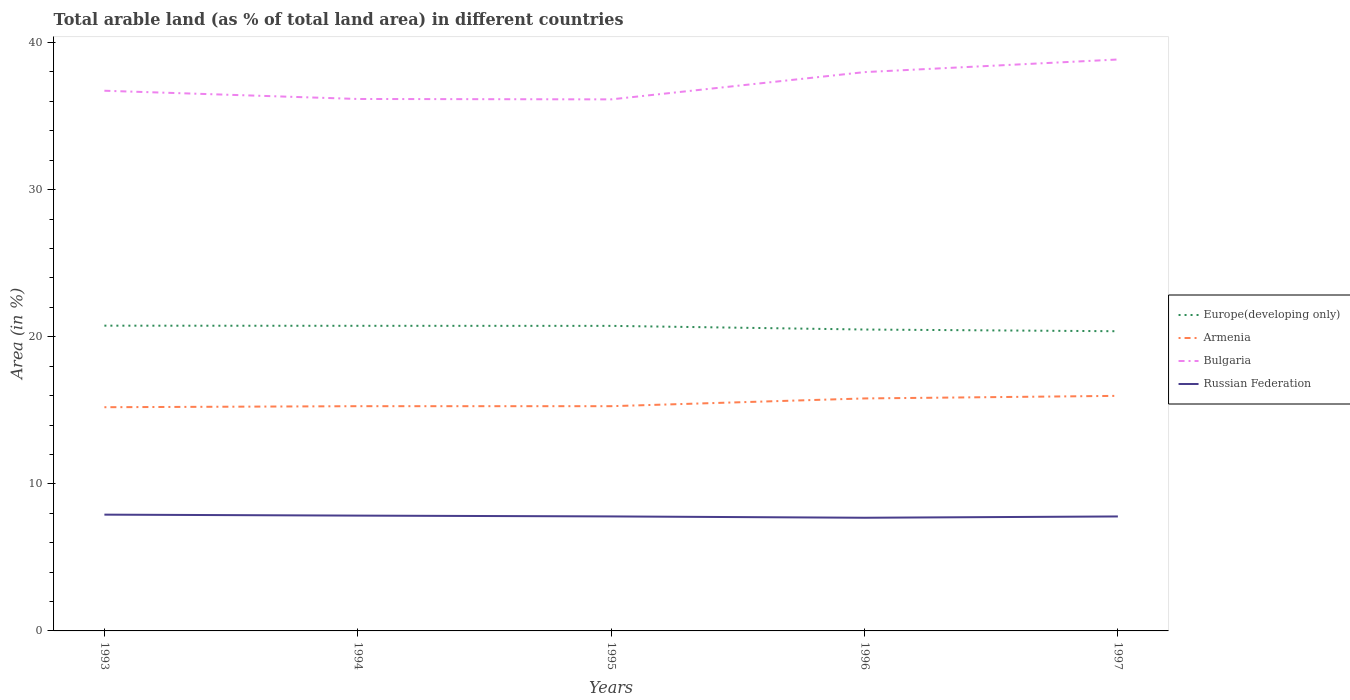Does the line corresponding to Russian Federation intersect with the line corresponding to Europe(developing only)?
Your answer should be very brief. No. Is the number of lines equal to the number of legend labels?
Offer a terse response. Yes. Across all years, what is the maximum percentage of arable land in Europe(developing only)?
Offer a very short reply. 20.37. What is the total percentage of arable land in Russian Federation in the graph?
Your answer should be very brief. 0.06. What is the difference between the highest and the second highest percentage of arable land in Bulgaria?
Your answer should be compact. 2.71. Is the percentage of arable land in Armenia strictly greater than the percentage of arable land in Europe(developing only) over the years?
Make the answer very short. Yes. How many lines are there?
Offer a terse response. 4. How many years are there in the graph?
Ensure brevity in your answer.  5. How many legend labels are there?
Provide a succinct answer. 4. How are the legend labels stacked?
Give a very brief answer. Vertical. What is the title of the graph?
Ensure brevity in your answer.  Total arable land (as % of total land area) in different countries. Does "Nigeria" appear as one of the legend labels in the graph?
Make the answer very short. No. What is the label or title of the Y-axis?
Offer a terse response. Area (in %). What is the Area (in %) of Europe(developing only) in 1993?
Provide a short and direct response. 20.75. What is the Area (in %) in Armenia in 1993?
Your response must be concise. 15.21. What is the Area (in %) in Bulgaria in 1993?
Provide a succinct answer. 36.73. What is the Area (in %) in Russian Federation in 1993?
Give a very brief answer. 7.91. What is the Area (in %) of Europe(developing only) in 1994?
Keep it short and to the point. 20.74. What is the Area (in %) in Armenia in 1994?
Keep it short and to the point. 15.28. What is the Area (in %) in Bulgaria in 1994?
Provide a succinct answer. 36.17. What is the Area (in %) of Russian Federation in 1994?
Give a very brief answer. 7.84. What is the Area (in %) of Europe(developing only) in 1995?
Ensure brevity in your answer.  20.74. What is the Area (in %) in Armenia in 1995?
Your response must be concise. 15.28. What is the Area (in %) of Bulgaria in 1995?
Offer a terse response. 36.14. What is the Area (in %) in Russian Federation in 1995?
Offer a terse response. 7.78. What is the Area (in %) of Europe(developing only) in 1996?
Give a very brief answer. 20.49. What is the Area (in %) in Armenia in 1996?
Provide a short and direct response. 15.81. What is the Area (in %) of Bulgaria in 1996?
Give a very brief answer. 37.99. What is the Area (in %) of Russian Federation in 1996?
Make the answer very short. 7.69. What is the Area (in %) in Europe(developing only) in 1997?
Your answer should be compact. 20.37. What is the Area (in %) in Armenia in 1997?
Make the answer very short. 15.98. What is the Area (in %) in Bulgaria in 1997?
Keep it short and to the point. 38.85. What is the Area (in %) in Russian Federation in 1997?
Offer a terse response. 7.78. Across all years, what is the maximum Area (in %) in Europe(developing only)?
Provide a short and direct response. 20.75. Across all years, what is the maximum Area (in %) of Armenia?
Offer a terse response. 15.98. Across all years, what is the maximum Area (in %) in Bulgaria?
Offer a terse response. 38.85. Across all years, what is the maximum Area (in %) in Russian Federation?
Provide a short and direct response. 7.91. Across all years, what is the minimum Area (in %) in Europe(developing only)?
Your answer should be very brief. 20.37. Across all years, what is the minimum Area (in %) in Armenia?
Provide a succinct answer. 15.21. Across all years, what is the minimum Area (in %) in Bulgaria?
Offer a terse response. 36.14. Across all years, what is the minimum Area (in %) of Russian Federation?
Offer a very short reply. 7.69. What is the total Area (in %) in Europe(developing only) in the graph?
Give a very brief answer. 103.1. What is the total Area (in %) in Armenia in the graph?
Give a very brief answer. 77.56. What is the total Area (in %) in Bulgaria in the graph?
Your answer should be very brief. 185.87. What is the total Area (in %) in Russian Federation in the graph?
Provide a short and direct response. 39.01. What is the difference between the Area (in %) of Europe(developing only) in 1993 and that in 1994?
Ensure brevity in your answer.  0.01. What is the difference between the Area (in %) of Armenia in 1993 and that in 1994?
Offer a terse response. -0.07. What is the difference between the Area (in %) of Bulgaria in 1993 and that in 1994?
Ensure brevity in your answer.  0.56. What is the difference between the Area (in %) in Russian Federation in 1993 and that in 1994?
Give a very brief answer. 0.07. What is the difference between the Area (in %) in Europe(developing only) in 1993 and that in 1995?
Offer a terse response. 0.01. What is the difference between the Area (in %) in Armenia in 1993 and that in 1995?
Keep it short and to the point. -0.07. What is the difference between the Area (in %) in Bulgaria in 1993 and that in 1995?
Provide a succinct answer. 0.59. What is the difference between the Area (in %) in Russian Federation in 1993 and that in 1995?
Provide a succinct answer. 0.12. What is the difference between the Area (in %) in Europe(developing only) in 1993 and that in 1996?
Provide a succinct answer. 0.26. What is the difference between the Area (in %) of Armenia in 1993 and that in 1996?
Provide a succinct answer. -0.6. What is the difference between the Area (in %) in Bulgaria in 1993 and that in 1996?
Make the answer very short. -1.27. What is the difference between the Area (in %) of Russian Federation in 1993 and that in 1996?
Offer a terse response. 0.21. What is the difference between the Area (in %) in Europe(developing only) in 1993 and that in 1997?
Provide a short and direct response. 0.38. What is the difference between the Area (in %) in Armenia in 1993 and that in 1997?
Offer a terse response. -0.77. What is the difference between the Area (in %) of Bulgaria in 1993 and that in 1997?
Keep it short and to the point. -2.12. What is the difference between the Area (in %) of Russian Federation in 1993 and that in 1997?
Your answer should be very brief. 0.12. What is the difference between the Area (in %) in Europe(developing only) in 1994 and that in 1995?
Ensure brevity in your answer.  0. What is the difference between the Area (in %) in Armenia in 1994 and that in 1995?
Your answer should be very brief. 0. What is the difference between the Area (in %) in Bulgaria in 1994 and that in 1995?
Give a very brief answer. 0.03. What is the difference between the Area (in %) of Russian Federation in 1994 and that in 1995?
Keep it short and to the point. 0.05. What is the difference between the Area (in %) in Europe(developing only) in 1994 and that in 1996?
Your response must be concise. 0.25. What is the difference between the Area (in %) of Armenia in 1994 and that in 1996?
Offer a very short reply. -0.53. What is the difference between the Area (in %) in Bulgaria in 1994 and that in 1996?
Give a very brief answer. -1.83. What is the difference between the Area (in %) of Russian Federation in 1994 and that in 1996?
Ensure brevity in your answer.  0.14. What is the difference between the Area (in %) of Europe(developing only) in 1994 and that in 1997?
Offer a terse response. 0.37. What is the difference between the Area (in %) in Armenia in 1994 and that in 1997?
Your response must be concise. -0.7. What is the difference between the Area (in %) in Bulgaria in 1994 and that in 1997?
Your response must be concise. -2.68. What is the difference between the Area (in %) of Russian Federation in 1994 and that in 1997?
Make the answer very short. 0.06. What is the difference between the Area (in %) in Europe(developing only) in 1995 and that in 1996?
Provide a succinct answer. 0.25. What is the difference between the Area (in %) in Armenia in 1995 and that in 1996?
Your answer should be compact. -0.53. What is the difference between the Area (in %) in Bulgaria in 1995 and that in 1996?
Your answer should be compact. -1.85. What is the difference between the Area (in %) of Russian Federation in 1995 and that in 1996?
Your answer should be very brief. 0.09. What is the difference between the Area (in %) of Europe(developing only) in 1995 and that in 1997?
Your response must be concise. 0.37. What is the difference between the Area (in %) of Armenia in 1995 and that in 1997?
Your answer should be compact. -0.7. What is the difference between the Area (in %) in Bulgaria in 1995 and that in 1997?
Your response must be concise. -2.71. What is the difference between the Area (in %) of Russian Federation in 1995 and that in 1997?
Offer a very short reply. 0. What is the difference between the Area (in %) of Europe(developing only) in 1996 and that in 1997?
Your answer should be compact. 0.12. What is the difference between the Area (in %) in Armenia in 1996 and that in 1997?
Your response must be concise. -0.18. What is the difference between the Area (in %) in Bulgaria in 1996 and that in 1997?
Your response must be concise. -0.86. What is the difference between the Area (in %) of Russian Federation in 1996 and that in 1997?
Give a very brief answer. -0.09. What is the difference between the Area (in %) of Europe(developing only) in 1993 and the Area (in %) of Armenia in 1994?
Your response must be concise. 5.47. What is the difference between the Area (in %) of Europe(developing only) in 1993 and the Area (in %) of Bulgaria in 1994?
Offer a terse response. -15.41. What is the difference between the Area (in %) in Europe(developing only) in 1993 and the Area (in %) in Russian Federation in 1994?
Keep it short and to the point. 12.91. What is the difference between the Area (in %) in Armenia in 1993 and the Area (in %) in Bulgaria in 1994?
Provide a succinct answer. -20.96. What is the difference between the Area (in %) of Armenia in 1993 and the Area (in %) of Russian Federation in 1994?
Offer a very short reply. 7.37. What is the difference between the Area (in %) in Bulgaria in 1993 and the Area (in %) in Russian Federation in 1994?
Provide a succinct answer. 28.89. What is the difference between the Area (in %) of Europe(developing only) in 1993 and the Area (in %) of Armenia in 1995?
Provide a short and direct response. 5.47. What is the difference between the Area (in %) in Europe(developing only) in 1993 and the Area (in %) in Bulgaria in 1995?
Offer a very short reply. -15.38. What is the difference between the Area (in %) in Europe(developing only) in 1993 and the Area (in %) in Russian Federation in 1995?
Your answer should be very brief. 12.97. What is the difference between the Area (in %) in Armenia in 1993 and the Area (in %) in Bulgaria in 1995?
Your response must be concise. -20.93. What is the difference between the Area (in %) in Armenia in 1993 and the Area (in %) in Russian Federation in 1995?
Provide a succinct answer. 7.42. What is the difference between the Area (in %) in Bulgaria in 1993 and the Area (in %) in Russian Federation in 1995?
Your response must be concise. 28.94. What is the difference between the Area (in %) in Europe(developing only) in 1993 and the Area (in %) in Armenia in 1996?
Your answer should be compact. 4.95. What is the difference between the Area (in %) of Europe(developing only) in 1993 and the Area (in %) of Bulgaria in 1996?
Your answer should be very brief. -17.24. What is the difference between the Area (in %) in Europe(developing only) in 1993 and the Area (in %) in Russian Federation in 1996?
Offer a terse response. 13.06. What is the difference between the Area (in %) in Armenia in 1993 and the Area (in %) in Bulgaria in 1996?
Offer a very short reply. -22.78. What is the difference between the Area (in %) in Armenia in 1993 and the Area (in %) in Russian Federation in 1996?
Provide a succinct answer. 7.51. What is the difference between the Area (in %) of Bulgaria in 1993 and the Area (in %) of Russian Federation in 1996?
Offer a very short reply. 29.03. What is the difference between the Area (in %) in Europe(developing only) in 1993 and the Area (in %) in Armenia in 1997?
Make the answer very short. 4.77. What is the difference between the Area (in %) of Europe(developing only) in 1993 and the Area (in %) of Bulgaria in 1997?
Give a very brief answer. -18.1. What is the difference between the Area (in %) of Europe(developing only) in 1993 and the Area (in %) of Russian Federation in 1997?
Make the answer very short. 12.97. What is the difference between the Area (in %) in Armenia in 1993 and the Area (in %) in Bulgaria in 1997?
Make the answer very short. -23.64. What is the difference between the Area (in %) of Armenia in 1993 and the Area (in %) of Russian Federation in 1997?
Give a very brief answer. 7.43. What is the difference between the Area (in %) of Bulgaria in 1993 and the Area (in %) of Russian Federation in 1997?
Offer a very short reply. 28.94. What is the difference between the Area (in %) in Europe(developing only) in 1994 and the Area (in %) in Armenia in 1995?
Offer a very short reply. 5.47. What is the difference between the Area (in %) in Europe(developing only) in 1994 and the Area (in %) in Bulgaria in 1995?
Give a very brief answer. -15.39. What is the difference between the Area (in %) of Europe(developing only) in 1994 and the Area (in %) of Russian Federation in 1995?
Provide a succinct answer. 12.96. What is the difference between the Area (in %) of Armenia in 1994 and the Area (in %) of Bulgaria in 1995?
Offer a very short reply. -20.86. What is the difference between the Area (in %) of Armenia in 1994 and the Area (in %) of Russian Federation in 1995?
Offer a terse response. 7.49. What is the difference between the Area (in %) of Bulgaria in 1994 and the Area (in %) of Russian Federation in 1995?
Your answer should be very brief. 28.38. What is the difference between the Area (in %) in Europe(developing only) in 1994 and the Area (in %) in Armenia in 1996?
Your response must be concise. 4.94. What is the difference between the Area (in %) in Europe(developing only) in 1994 and the Area (in %) in Bulgaria in 1996?
Give a very brief answer. -17.25. What is the difference between the Area (in %) in Europe(developing only) in 1994 and the Area (in %) in Russian Federation in 1996?
Offer a very short reply. 13.05. What is the difference between the Area (in %) in Armenia in 1994 and the Area (in %) in Bulgaria in 1996?
Provide a short and direct response. -22.71. What is the difference between the Area (in %) in Armenia in 1994 and the Area (in %) in Russian Federation in 1996?
Your answer should be very brief. 7.58. What is the difference between the Area (in %) in Bulgaria in 1994 and the Area (in %) in Russian Federation in 1996?
Offer a very short reply. 28.47. What is the difference between the Area (in %) in Europe(developing only) in 1994 and the Area (in %) in Armenia in 1997?
Make the answer very short. 4.76. What is the difference between the Area (in %) in Europe(developing only) in 1994 and the Area (in %) in Bulgaria in 1997?
Ensure brevity in your answer.  -18.11. What is the difference between the Area (in %) in Europe(developing only) in 1994 and the Area (in %) in Russian Federation in 1997?
Provide a short and direct response. 12.96. What is the difference between the Area (in %) of Armenia in 1994 and the Area (in %) of Bulgaria in 1997?
Ensure brevity in your answer.  -23.57. What is the difference between the Area (in %) of Armenia in 1994 and the Area (in %) of Russian Federation in 1997?
Keep it short and to the point. 7.5. What is the difference between the Area (in %) in Bulgaria in 1994 and the Area (in %) in Russian Federation in 1997?
Your answer should be compact. 28.38. What is the difference between the Area (in %) of Europe(developing only) in 1995 and the Area (in %) of Armenia in 1996?
Keep it short and to the point. 4.93. What is the difference between the Area (in %) of Europe(developing only) in 1995 and the Area (in %) of Bulgaria in 1996?
Provide a succinct answer. -17.25. What is the difference between the Area (in %) in Europe(developing only) in 1995 and the Area (in %) in Russian Federation in 1996?
Make the answer very short. 13.05. What is the difference between the Area (in %) of Armenia in 1995 and the Area (in %) of Bulgaria in 1996?
Offer a very short reply. -22.71. What is the difference between the Area (in %) of Armenia in 1995 and the Area (in %) of Russian Federation in 1996?
Provide a short and direct response. 7.58. What is the difference between the Area (in %) in Bulgaria in 1995 and the Area (in %) in Russian Federation in 1996?
Make the answer very short. 28.44. What is the difference between the Area (in %) in Europe(developing only) in 1995 and the Area (in %) in Armenia in 1997?
Provide a short and direct response. 4.76. What is the difference between the Area (in %) in Europe(developing only) in 1995 and the Area (in %) in Bulgaria in 1997?
Provide a short and direct response. -18.11. What is the difference between the Area (in %) of Europe(developing only) in 1995 and the Area (in %) of Russian Federation in 1997?
Keep it short and to the point. 12.96. What is the difference between the Area (in %) of Armenia in 1995 and the Area (in %) of Bulgaria in 1997?
Provide a succinct answer. -23.57. What is the difference between the Area (in %) in Armenia in 1995 and the Area (in %) in Russian Federation in 1997?
Make the answer very short. 7.5. What is the difference between the Area (in %) in Bulgaria in 1995 and the Area (in %) in Russian Federation in 1997?
Your answer should be very brief. 28.36. What is the difference between the Area (in %) of Europe(developing only) in 1996 and the Area (in %) of Armenia in 1997?
Keep it short and to the point. 4.51. What is the difference between the Area (in %) in Europe(developing only) in 1996 and the Area (in %) in Bulgaria in 1997?
Offer a terse response. -18.36. What is the difference between the Area (in %) in Europe(developing only) in 1996 and the Area (in %) in Russian Federation in 1997?
Ensure brevity in your answer.  12.71. What is the difference between the Area (in %) of Armenia in 1996 and the Area (in %) of Bulgaria in 1997?
Offer a terse response. -23.04. What is the difference between the Area (in %) of Armenia in 1996 and the Area (in %) of Russian Federation in 1997?
Your answer should be very brief. 8.02. What is the difference between the Area (in %) in Bulgaria in 1996 and the Area (in %) in Russian Federation in 1997?
Your response must be concise. 30.21. What is the average Area (in %) of Europe(developing only) per year?
Keep it short and to the point. 20.62. What is the average Area (in %) in Armenia per year?
Ensure brevity in your answer.  15.51. What is the average Area (in %) in Bulgaria per year?
Provide a short and direct response. 37.17. What is the average Area (in %) of Russian Federation per year?
Your response must be concise. 7.8. In the year 1993, what is the difference between the Area (in %) of Europe(developing only) and Area (in %) of Armenia?
Offer a terse response. 5.54. In the year 1993, what is the difference between the Area (in %) of Europe(developing only) and Area (in %) of Bulgaria?
Provide a succinct answer. -15.97. In the year 1993, what is the difference between the Area (in %) in Europe(developing only) and Area (in %) in Russian Federation?
Your response must be concise. 12.85. In the year 1993, what is the difference between the Area (in %) in Armenia and Area (in %) in Bulgaria?
Make the answer very short. -21.52. In the year 1993, what is the difference between the Area (in %) in Armenia and Area (in %) in Russian Federation?
Your answer should be compact. 7.3. In the year 1993, what is the difference between the Area (in %) in Bulgaria and Area (in %) in Russian Federation?
Your response must be concise. 28.82. In the year 1994, what is the difference between the Area (in %) of Europe(developing only) and Area (in %) of Armenia?
Provide a succinct answer. 5.47. In the year 1994, what is the difference between the Area (in %) in Europe(developing only) and Area (in %) in Bulgaria?
Your response must be concise. -15.42. In the year 1994, what is the difference between the Area (in %) in Europe(developing only) and Area (in %) in Russian Federation?
Provide a short and direct response. 12.9. In the year 1994, what is the difference between the Area (in %) in Armenia and Area (in %) in Bulgaria?
Provide a succinct answer. -20.89. In the year 1994, what is the difference between the Area (in %) of Armenia and Area (in %) of Russian Federation?
Your answer should be compact. 7.44. In the year 1994, what is the difference between the Area (in %) of Bulgaria and Area (in %) of Russian Federation?
Make the answer very short. 28.33. In the year 1995, what is the difference between the Area (in %) in Europe(developing only) and Area (in %) in Armenia?
Your response must be concise. 5.46. In the year 1995, what is the difference between the Area (in %) of Europe(developing only) and Area (in %) of Bulgaria?
Ensure brevity in your answer.  -15.4. In the year 1995, what is the difference between the Area (in %) of Europe(developing only) and Area (in %) of Russian Federation?
Your response must be concise. 12.96. In the year 1995, what is the difference between the Area (in %) of Armenia and Area (in %) of Bulgaria?
Offer a terse response. -20.86. In the year 1995, what is the difference between the Area (in %) in Armenia and Area (in %) in Russian Federation?
Keep it short and to the point. 7.49. In the year 1995, what is the difference between the Area (in %) in Bulgaria and Area (in %) in Russian Federation?
Give a very brief answer. 28.35. In the year 1996, what is the difference between the Area (in %) of Europe(developing only) and Area (in %) of Armenia?
Offer a terse response. 4.69. In the year 1996, what is the difference between the Area (in %) in Europe(developing only) and Area (in %) in Bulgaria?
Keep it short and to the point. -17.5. In the year 1996, what is the difference between the Area (in %) in Europe(developing only) and Area (in %) in Russian Federation?
Offer a terse response. 12.8. In the year 1996, what is the difference between the Area (in %) in Armenia and Area (in %) in Bulgaria?
Provide a succinct answer. -22.19. In the year 1996, what is the difference between the Area (in %) in Armenia and Area (in %) in Russian Federation?
Make the answer very short. 8.11. In the year 1996, what is the difference between the Area (in %) in Bulgaria and Area (in %) in Russian Federation?
Provide a short and direct response. 30.3. In the year 1997, what is the difference between the Area (in %) of Europe(developing only) and Area (in %) of Armenia?
Offer a terse response. 4.39. In the year 1997, what is the difference between the Area (in %) in Europe(developing only) and Area (in %) in Bulgaria?
Your answer should be compact. -18.48. In the year 1997, what is the difference between the Area (in %) in Europe(developing only) and Area (in %) in Russian Federation?
Your response must be concise. 12.59. In the year 1997, what is the difference between the Area (in %) of Armenia and Area (in %) of Bulgaria?
Provide a short and direct response. -22.87. In the year 1997, what is the difference between the Area (in %) in Armenia and Area (in %) in Russian Federation?
Offer a terse response. 8.2. In the year 1997, what is the difference between the Area (in %) of Bulgaria and Area (in %) of Russian Federation?
Your answer should be very brief. 31.07. What is the ratio of the Area (in %) in Armenia in 1993 to that in 1994?
Offer a terse response. 1. What is the ratio of the Area (in %) of Bulgaria in 1993 to that in 1994?
Keep it short and to the point. 1.02. What is the ratio of the Area (in %) in Russian Federation in 1993 to that in 1994?
Keep it short and to the point. 1.01. What is the ratio of the Area (in %) of Europe(developing only) in 1993 to that in 1995?
Give a very brief answer. 1. What is the ratio of the Area (in %) of Armenia in 1993 to that in 1995?
Provide a succinct answer. 1. What is the ratio of the Area (in %) in Bulgaria in 1993 to that in 1995?
Your answer should be very brief. 1.02. What is the ratio of the Area (in %) of Russian Federation in 1993 to that in 1995?
Keep it short and to the point. 1.02. What is the ratio of the Area (in %) in Europe(developing only) in 1993 to that in 1996?
Provide a succinct answer. 1.01. What is the ratio of the Area (in %) of Armenia in 1993 to that in 1996?
Your answer should be very brief. 0.96. What is the ratio of the Area (in %) of Bulgaria in 1993 to that in 1996?
Make the answer very short. 0.97. What is the ratio of the Area (in %) of Russian Federation in 1993 to that in 1996?
Offer a terse response. 1.03. What is the ratio of the Area (in %) of Europe(developing only) in 1993 to that in 1997?
Ensure brevity in your answer.  1.02. What is the ratio of the Area (in %) of Armenia in 1993 to that in 1997?
Keep it short and to the point. 0.95. What is the ratio of the Area (in %) in Bulgaria in 1993 to that in 1997?
Your answer should be compact. 0.95. What is the ratio of the Area (in %) in Russian Federation in 1993 to that in 1997?
Offer a very short reply. 1.02. What is the ratio of the Area (in %) in Armenia in 1994 to that in 1995?
Make the answer very short. 1. What is the ratio of the Area (in %) in Europe(developing only) in 1994 to that in 1996?
Your answer should be compact. 1.01. What is the ratio of the Area (in %) in Armenia in 1994 to that in 1996?
Ensure brevity in your answer.  0.97. What is the ratio of the Area (in %) in Bulgaria in 1994 to that in 1996?
Provide a short and direct response. 0.95. What is the ratio of the Area (in %) of Russian Federation in 1994 to that in 1996?
Your answer should be compact. 1.02. What is the ratio of the Area (in %) in Europe(developing only) in 1994 to that in 1997?
Give a very brief answer. 1.02. What is the ratio of the Area (in %) in Armenia in 1994 to that in 1997?
Offer a very short reply. 0.96. What is the ratio of the Area (in %) of Bulgaria in 1994 to that in 1997?
Your answer should be very brief. 0.93. What is the ratio of the Area (in %) in Russian Federation in 1994 to that in 1997?
Your answer should be very brief. 1.01. What is the ratio of the Area (in %) in Europe(developing only) in 1995 to that in 1996?
Your answer should be compact. 1.01. What is the ratio of the Area (in %) in Armenia in 1995 to that in 1996?
Make the answer very short. 0.97. What is the ratio of the Area (in %) of Bulgaria in 1995 to that in 1996?
Your answer should be compact. 0.95. What is the ratio of the Area (in %) in Russian Federation in 1995 to that in 1996?
Make the answer very short. 1.01. What is the ratio of the Area (in %) in Europe(developing only) in 1995 to that in 1997?
Give a very brief answer. 1.02. What is the ratio of the Area (in %) of Armenia in 1995 to that in 1997?
Provide a short and direct response. 0.96. What is the ratio of the Area (in %) of Bulgaria in 1995 to that in 1997?
Make the answer very short. 0.93. What is the ratio of the Area (in %) in Russian Federation in 1995 to that in 1997?
Your answer should be very brief. 1. What is the ratio of the Area (in %) in Europe(developing only) in 1996 to that in 1997?
Make the answer very short. 1.01. What is the ratio of the Area (in %) in Armenia in 1996 to that in 1997?
Make the answer very short. 0.99. What is the ratio of the Area (in %) in Bulgaria in 1996 to that in 1997?
Make the answer very short. 0.98. What is the ratio of the Area (in %) in Russian Federation in 1996 to that in 1997?
Your answer should be compact. 0.99. What is the difference between the highest and the second highest Area (in %) of Europe(developing only)?
Ensure brevity in your answer.  0.01. What is the difference between the highest and the second highest Area (in %) in Armenia?
Offer a terse response. 0.18. What is the difference between the highest and the second highest Area (in %) in Bulgaria?
Offer a terse response. 0.86. What is the difference between the highest and the second highest Area (in %) of Russian Federation?
Offer a terse response. 0.07. What is the difference between the highest and the lowest Area (in %) in Europe(developing only)?
Offer a very short reply. 0.38. What is the difference between the highest and the lowest Area (in %) of Armenia?
Your response must be concise. 0.77. What is the difference between the highest and the lowest Area (in %) in Bulgaria?
Give a very brief answer. 2.71. What is the difference between the highest and the lowest Area (in %) in Russian Federation?
Keep it short and to the point. 0.21. 